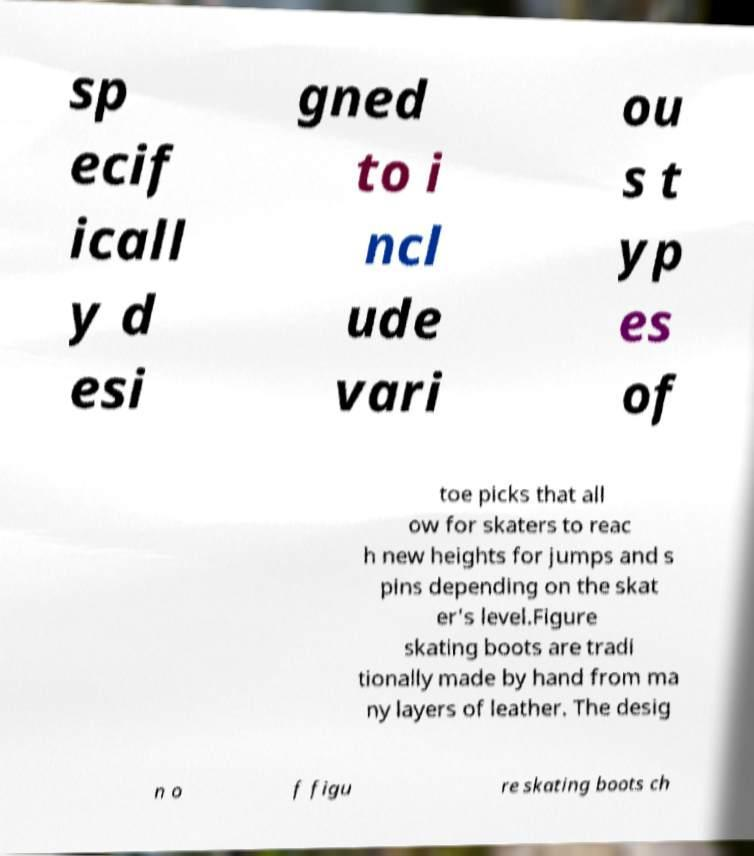There's text embedded in this image that I need extracted. Can you transcribe it verbatim? sp ecif icall y d esi gned to i ncl ude vari ou s t yp es of toe picks that all ow for skaters to reac h new heights for jumps and s pins depending on the skat er's level.Figure skating boots are tradi tionally made by hand from ma ny layers of leather. The desig n o f figu re skating boots ch 